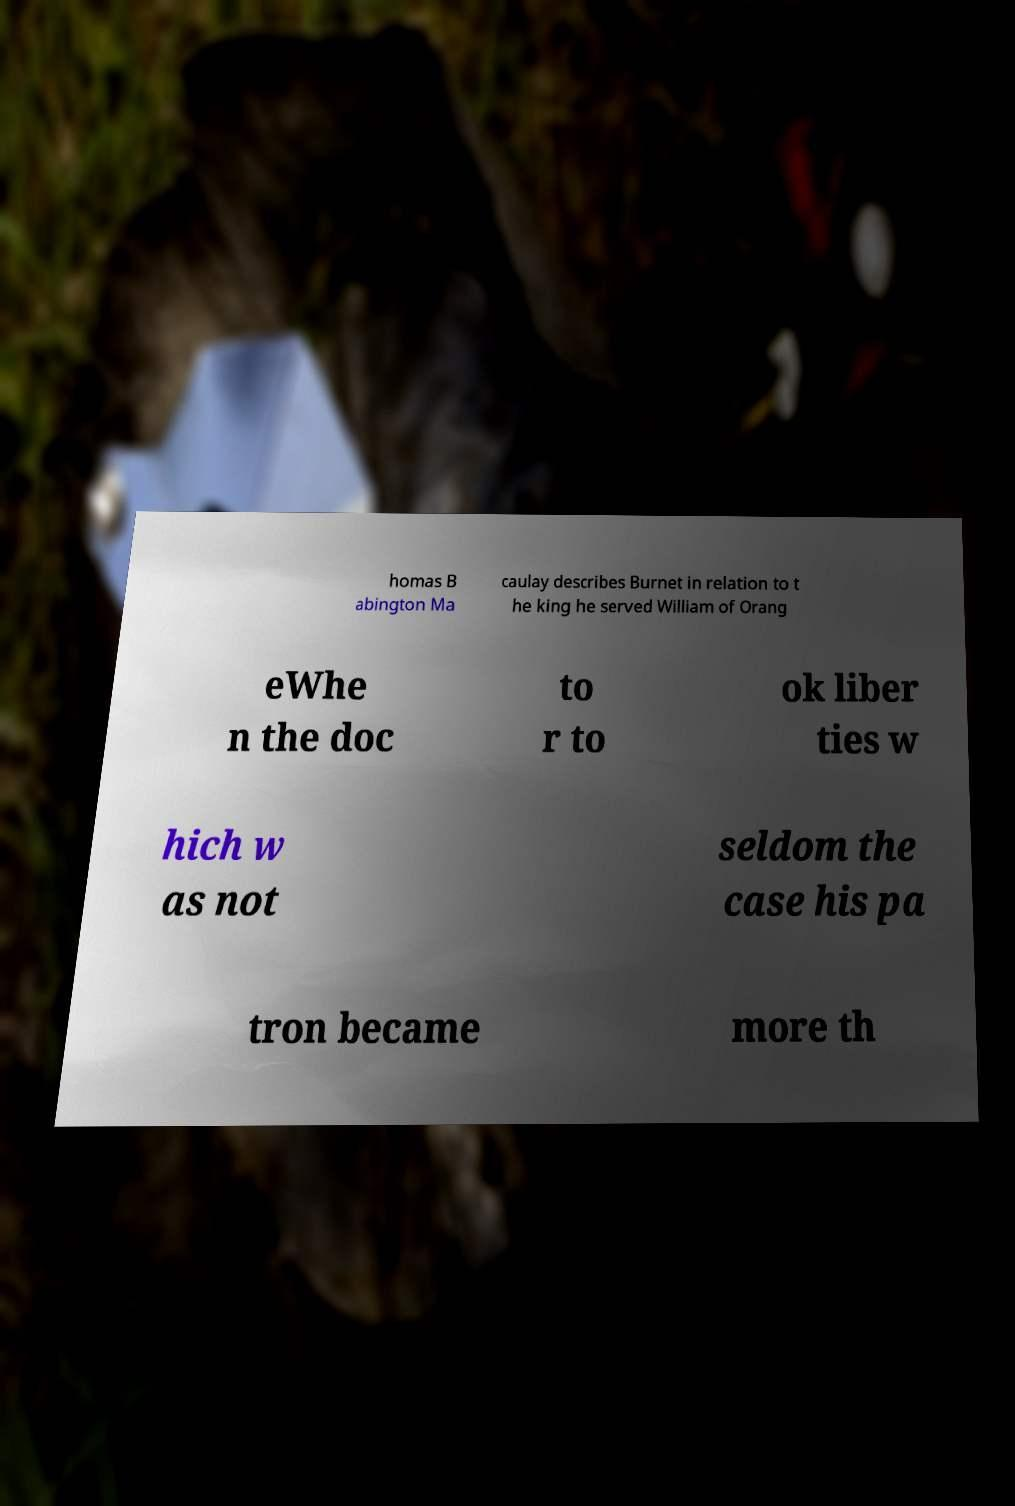Can you accurately transcribe the text from the provided image for me? homas B abington Ma caulay describes Burnet in relation to t he king he served William of Orang eWhe n the doc to r to ok liber ties w hich w as not seldom the case his pa tron became more th 